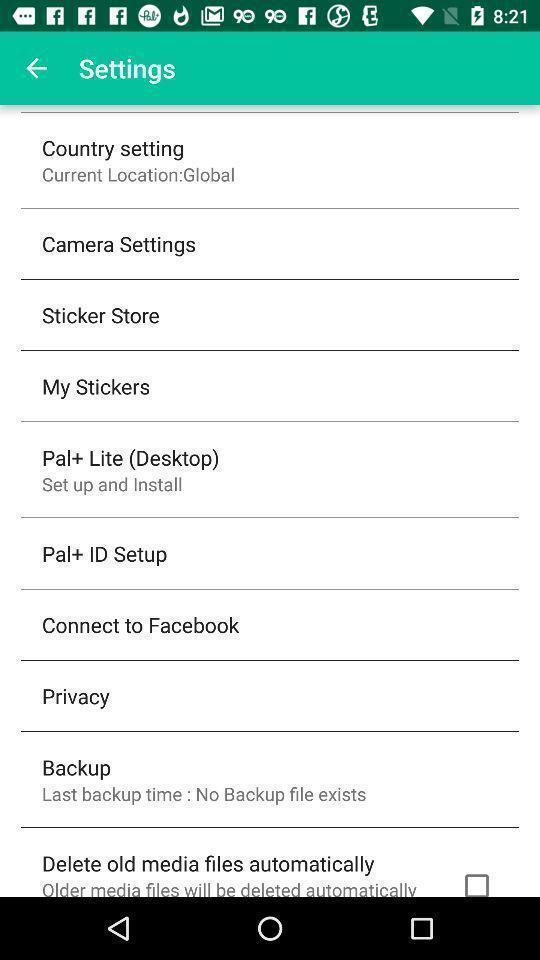Provide a detailed account of this screenshot. Screen displaying the settings page. 